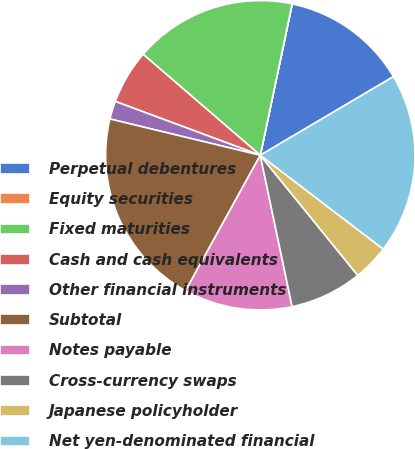Convert chart. <chart><loc_0><loc_0><loc_500><loc_500><pie_chart><fcel>Perpetual debentures<fcel>Equity securities<fcel>Fixed maturities<fcel>Cash and cash equivalents<fcel>Other financial instruments<fcel>Subtotal<fcel>Notes payable<fcel>Cross-currency swaps<fcel>Japanese policyholder<fcel>Net yen-denominated financial<nl><fcel>13.2%<fcel>0.01%<fcel>16.98%<fcel>5.66%<fcel>1.89%<fcel>20.75%<fcel>11.32%<fcel>7.55%<fcel>3.78%<fcel>18.86%<nl></chart> 